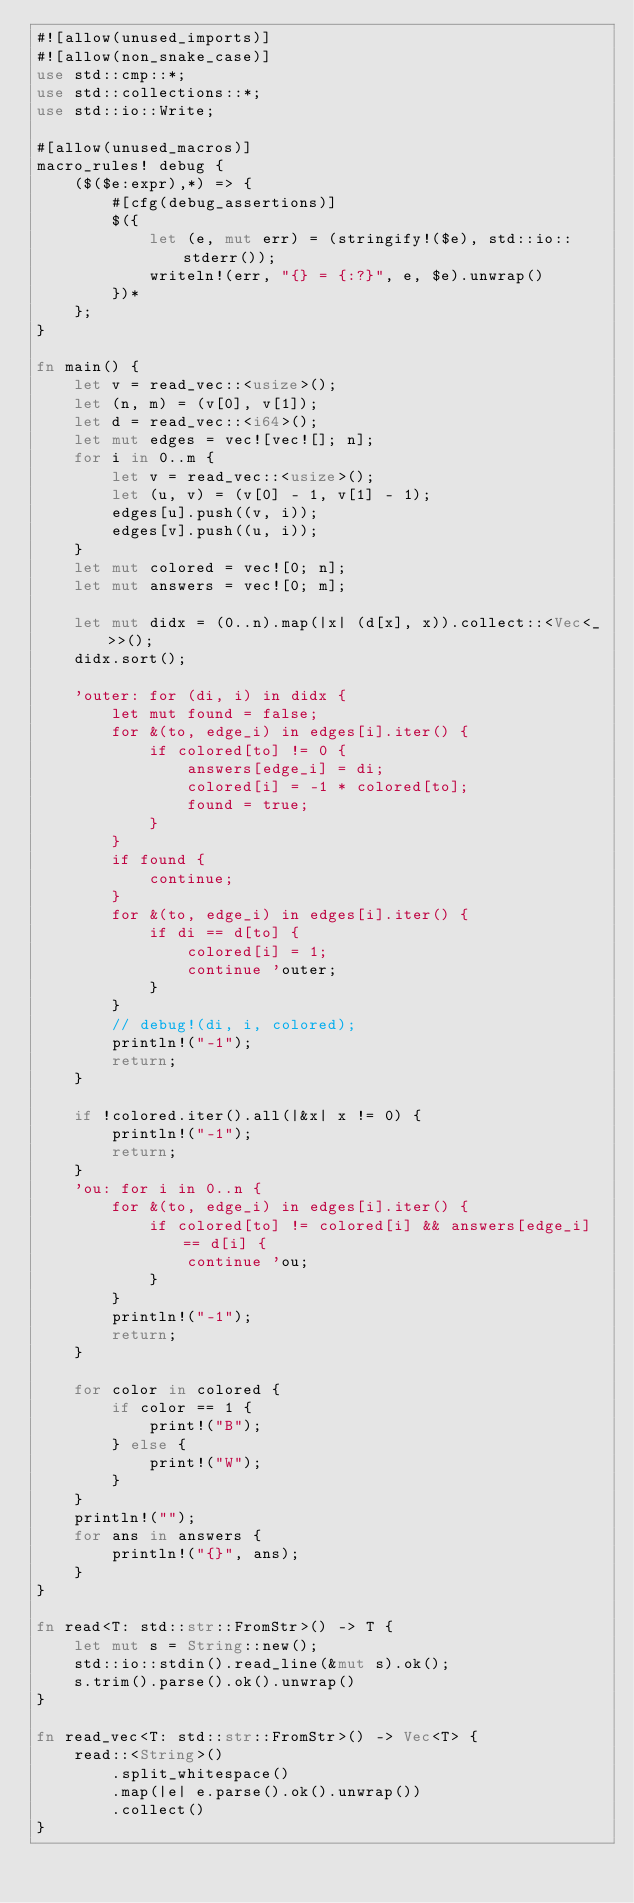<code> <loc_0><loc_0><loc_500><loc_500><_Rust_>#![allow(unused_imports)]
#![allow(non_snake_case)]
use std::cmp::*;
use std::collections::*;
use std::io::Write;

#[allow(unused_macros)]
macro_rules! debug {
    ($($e:expr),*) => {
        #[cfg(debug_assertions)]
        $({
            let (e, mut err) = (stringify!($e), std::io::stderr());
            writeln!(err, "{} = {:?}", e, $e).unwrap()
        })*
    };
}

fn main() {
    let v = read_vec::<usize>();
    let (n, m) = (v[0], v[1]);
    let d = read_vec::<i64>();
    let mut edges = vec![vec![]; n];
    for i in 0..m {
        let v = read_vec::<usize>();
        let (u, v) = (v[0] - 1, v[1] - 1);
        edges[u].push((v, i));
        edges[v].push((u, i));
    }
    let mut colored = vec![0; n];
    let mut answers = vec![0; m];

    let mut didx = (0..n).map(|x| (d[x], x)).collect::<Vec<_>>();
    didx.sort();

    'outer: for (di, i) in didx {
        let mut found = false;
        for &(to, edge_i) in edges[i].iter() {
            if colored[to] != 0 {
                answers[edge_i] = di;
                colored[i] = -1 * colored[to];
                found = true;
            }
        }
        if found {
            continue;
        }
        for &(to, edge_i) in edges[i].iter() {
            if di == d[to] {
                colored[i] = 1;
                continue 'outer;
            }
        }
        // debug!(di, i, colored);
        println!("-1");
        return;
    }

    if !colored.iter().all(|&x| x != 0) {
        println!("-1");
        return;
    }
    'ou: for i in 0..n {
        for &(to, edge_i) in edges[i].iter() {
            if colored[to] != colored[i] && answers[edge_i] == d[i] {
                continue 'ou;
            }
        }
        println!("-1");
        return;
    }

    for color in colored {
        if color == 1 {
            print!("B");
        } else {
            print!("W");
        }
    }
    println!("");
    for ans in answers {
        println!("{}", ans);
    }
}

fn read<T: std::str::FromStr>() -> T {
    let mut s = String::new();
    std::io::stdin().read_line(&mut s).ok();
    s.trim().parse().ok().unwrap()
}

fn read_vec<T: std::str::FromStr>() -> Vec<T> {
    read::<String>()
        .split_whitespace()
        .map(|e| e.parse().ok().unwrap())
        .collect()
}
</code> 